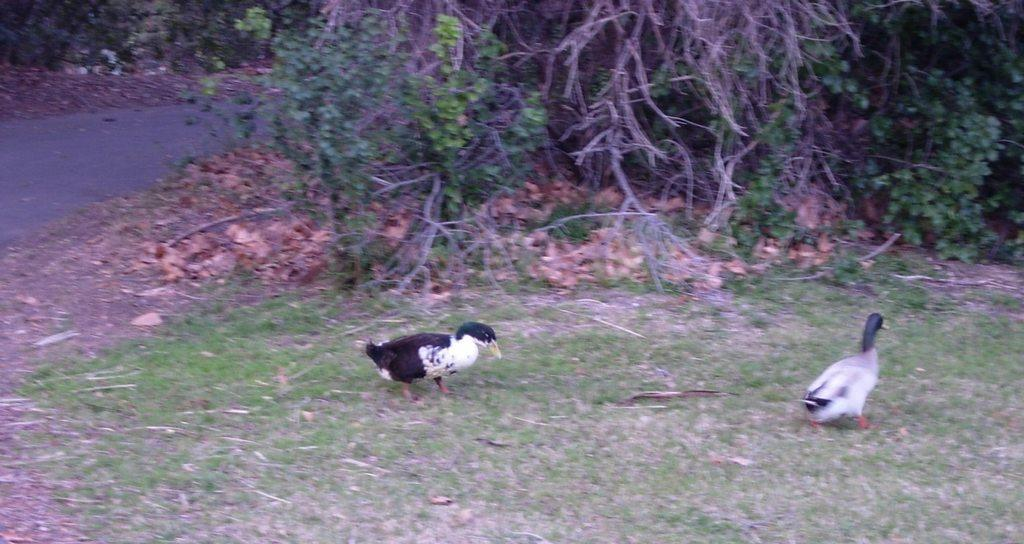How many birds can be seen in the image? There are two birds in the image. Where are the birds located? The birds are on the grass. What can be seen in the background of the image? There is a road and trees in the background of the image. What type of leaf is being delivered in a parcel in the image? There is no leaf or parcel present in the image; it features two birds on the grass with a background of a road and trees. 